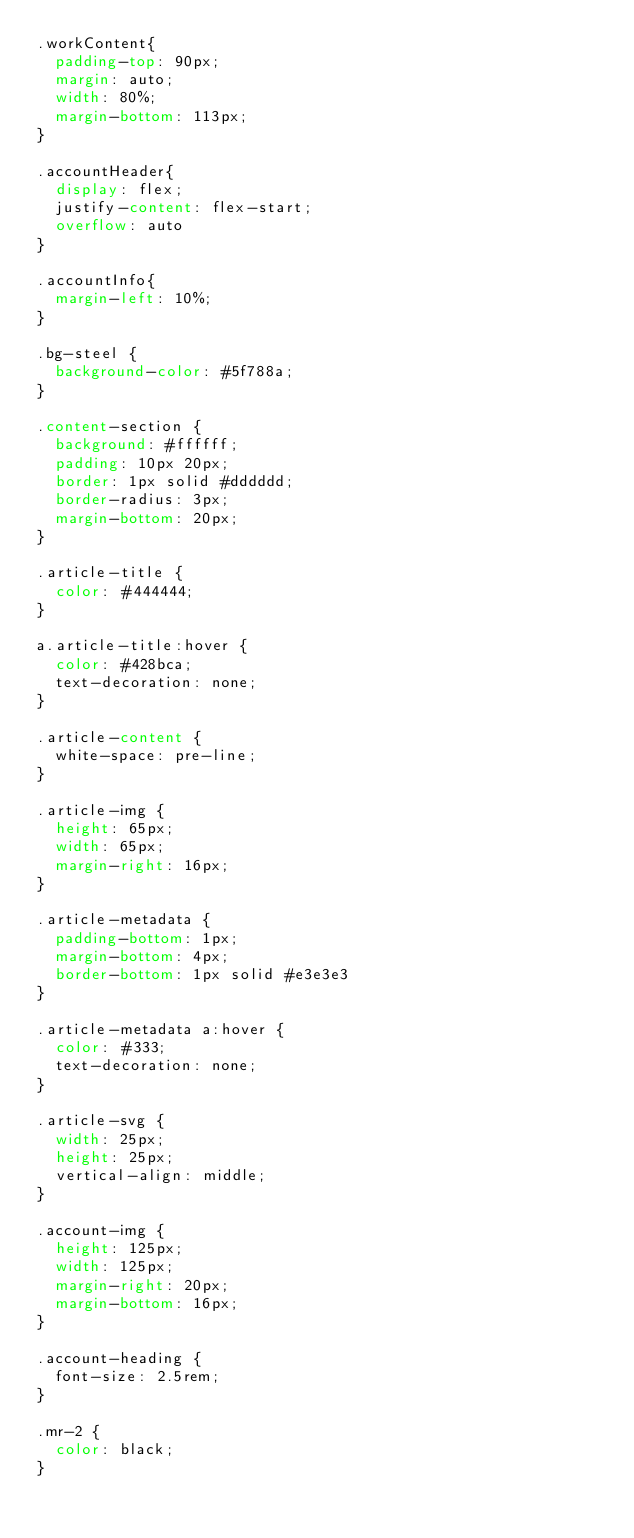Convert code to text. <code><loc_0><loc_0><loc_500><loc_500><_CSS_>.workContent{
  padding-top: 90px;
  margin: auto;
  width: 80%;
  margin-bottom: 113px;
}

.accountHeader{
  display: flex;
  justify-content: flex-start;
  overflow: auto
}

.accountInfo{
  margin-left: 10%;
}

.bg-steel {
  background-color: #5f788a;
}

.content-section {
  background: #ffffff;
  padding: 10px 20px;
  border: 1px solid #dddddd;
  border-radius: 3px;
  margin-bottom: 20px;
}

.article-title {
  color: #444444;
}

a.article-title:hover {
  color: #428bca;
  text-decoration: none;
}

.article-content {
  white-space: pre-line;
}

.article-img {
  height: 65px;
  width: 65px;
  margin-right: 16px;
}

.article-metadata {
  padding-bottom: 1px;
  margin-bottom: 4px;
  border-bottom: 1px solid #e3e3e3
}

.article-metadata a:hover {
  color: #333;
  text-decoration: none;
}

.article-svg {
  width: 25px;
  height: 25px;
  vertical-align: middle;
}

.account-img {
  height: 125px;
  width: 125px;
  margin-right: 20px;
  margin-bottom: 16px;
}

.account-heading {
  font-size: 2.5rem;
}

.mr-2 {
  color: black;
}
</code> 